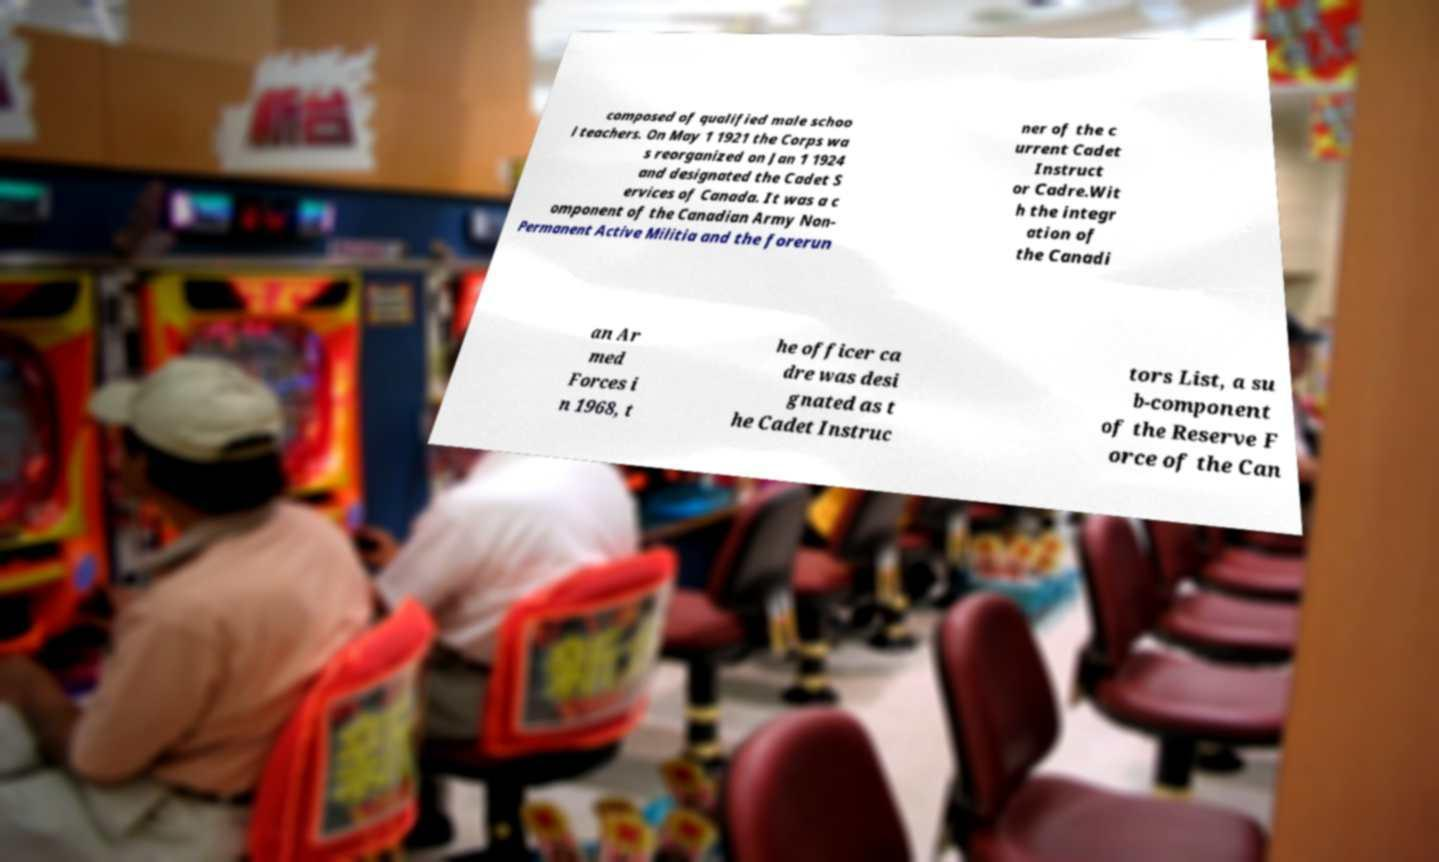I need the written content from this picture converted into text. Can you do that? composed of qualified male schoo l teachers. On May 1 1921 the Corps wa s reorganized on Jan 1 1924 and designated the Cadet S ervices of Canada. It was a c omponent of the Canadian Army Non- Permanent Active Militia and the forerun ner of the c urrent Cadet Instruct or Cadre.Wit h the integr ation of the Canadi an Ar med Forces i n 1968, t he officer ca dre was desi gnated as t he Cadet Instruc tors List, a su b-component of the Reserve F orce of the Can 